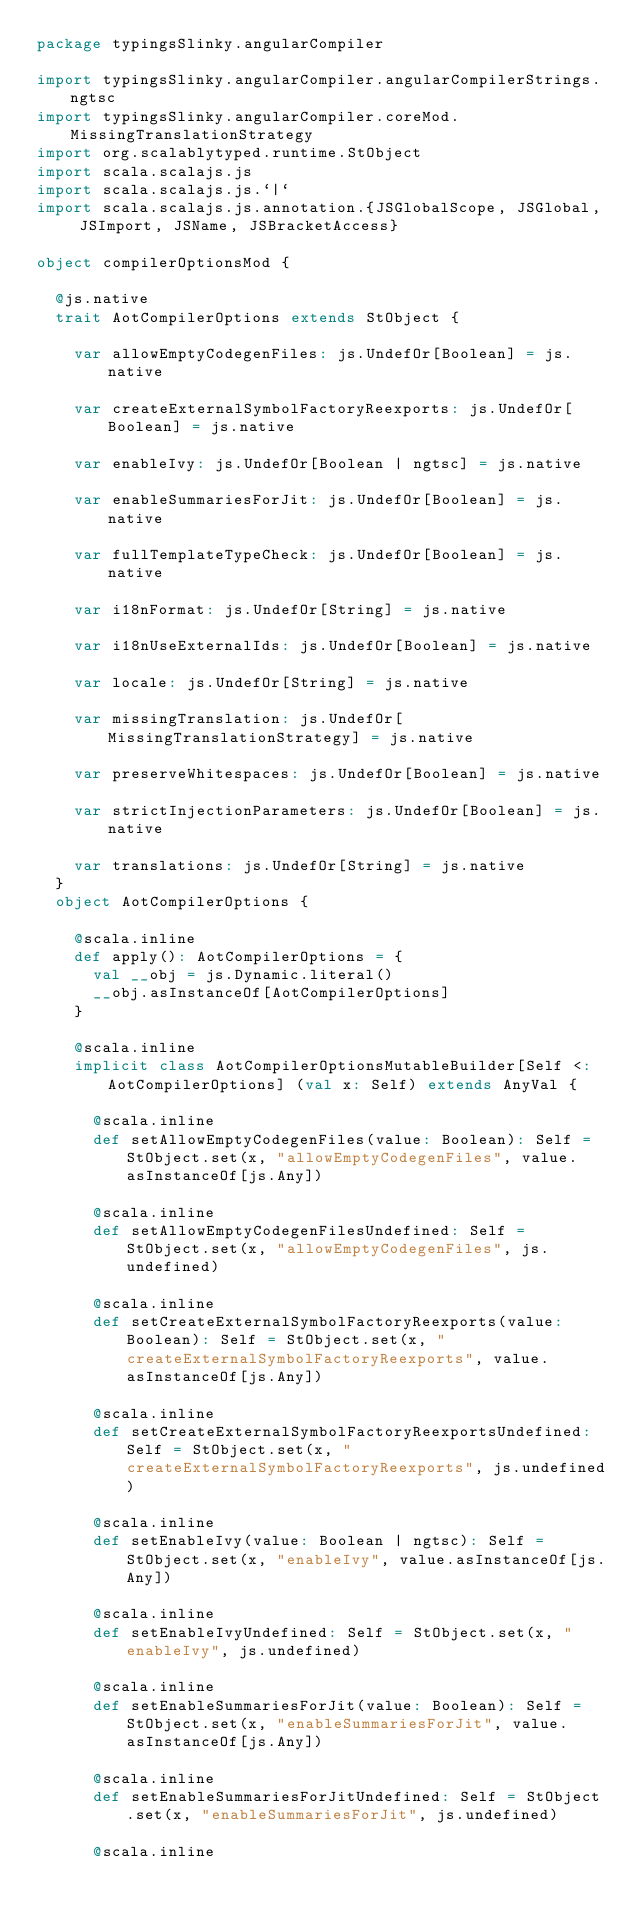Convert code to text. <code><loc_0><loc_0><loc_500><loc_500><_Scala_>package typingsSlinky.angularCompiler

import typingsSlinky.angularCompiler.angularCompilerStrings.ngtsc
import typingsSlinky.angularCompiler.coreMod.MissingTranslationStrategy
import org.scalablytyped.runtime.StObject
import scala.scalajs.js
import scala.scalajs.js.`|`
import scala.scalajs.js.annotation.{JSGlobalScope, JSGlobal, JSImport, JSName, JSBracketAccess}

object compilerOptionsMod {
  
  @js.native
  trait AotCompilerOptions extends StObject {
    
    var allowEmptyCodegenFiles: js.UndefOr[Boolean] = js.native
    
    var createExternalSymbolFactoryReexports: js.UndefOr[Boolean] = js.native
    
    var enableIvy: js.UndefOr[Boolean | ngtsc] = js.native
    
    var enableSummariesForJit: js.UndefOr[Boolean] = js.native
    
    var fullTemplateTypeCheck: js.UndefOr[Boolean] = js.native
    
    var i18nFormat: js.UndefOr[String] = js.native
    
    var i18nUseExternalIds: js.UndefOr[Boolean] = js.native
    
    var locale: js.UndefOr[String] = js.native
    
    var missingTranslation: js.UndefOr[MissingTranslationStrategy] = js.native
    
    var preserveWhitespaces: js.UndefOr[Boolean] = js.native
    
    var strictInjectionParameters: js.UndefOr[Boolean] = js.native
    
    var translations: js.UndefOr[String] = js.native
  }
  object AotCompilerOptions {
    
    @scala.inline
    def apply(): AotCompilerOptions = {
      val __obj = js.Dynamic.literal()
      __obj.asInstanceOf[AotCompilerOptions]
    }
    
    @scala.inline
    implicit class AotCompilerOptionsMutableBuilder[Self <: AotCompilerOptions] (val x: Self) extends AnyVal {
      
      @scala.inline
      def setAllowEmptyCodegenFiles(value: Boolean): Self = StObject.set(x, "allowEmptyCodegenFiles", value.asInstanceOf[js.Any])
      
      @scala.inline
      def setAllowEmptyCodegenFilesUndefined: Self = StObject.set(x, "allowEmptyCodegenFiles", js.undefined)
      
      @scala.inline
      def setCreateExternalSymbolFactoryReexports(value: Boolean): Self = StObject.set(x, "createExternalSymbolFactoryReexports", value.asInstanceOf[js.Any])
      
      @scala.inline
      def setCreateExternalSymbolFactoryReexportsUndefined: Self = StObject.set(x, "createExternalSymbolFactoryReexports", js.undefined)
      
      @scala.inline
      def setEnableIvy(value: Boolean | ngtsc): Self = StObject.set(x, "enableIvy", value.asInstanceOf[js.Any])
      
      @scala.inline
      def setEnableIvyUndefined: Self = StObject.set(x, "enableIvy", js.undefined)
      
      @scala.inline
      def setEnableSummariesForJit(value: Boolean): Self = StObject.set(x, "enableSummariesForJit", value.asInstanceOf[js.Any])
      
      @scala.inline
      def setEnableSummariesForJitUndefined: Self = StObject.set(x, "enableSummariesForJit", js.undefined)
      
      @scala.inline</code> 